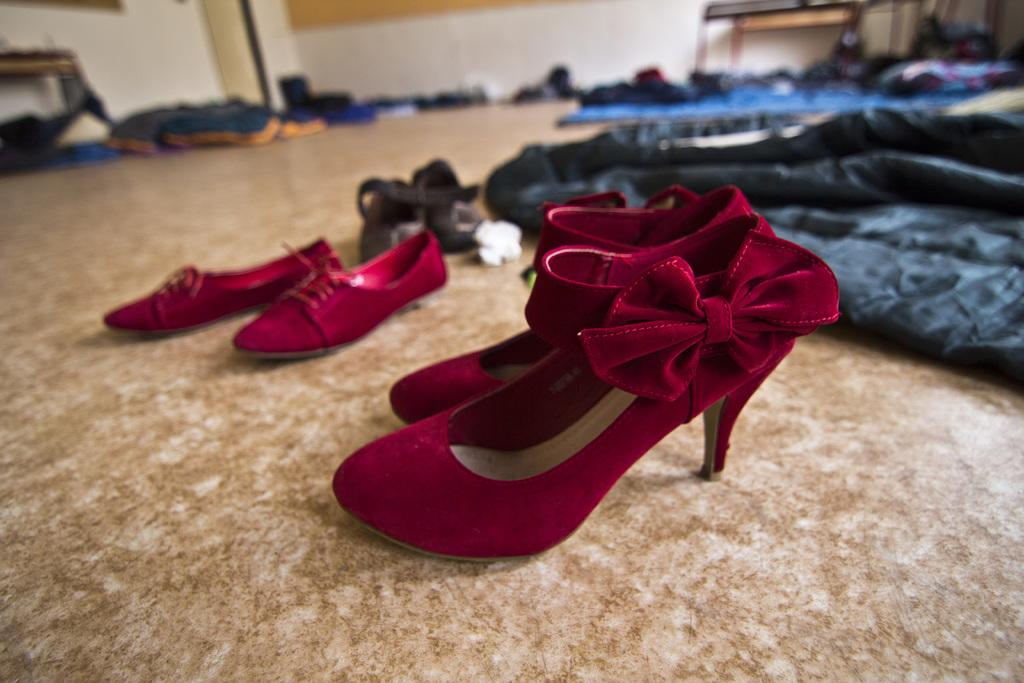What type of items can be seen on the floor in the image? There are footwear, clothes, and other objects on the floor in the image. What type of furniture is present in the image? There are tables in the image. What type of architectural features can be seen in the image? There is a wall and a door in the image. Can you see any horses playing on the playground in the image? There is no playground or horses present in the image. How is the knot tied on the clothes in the image? There are no knots visible on the clothes in the image. 